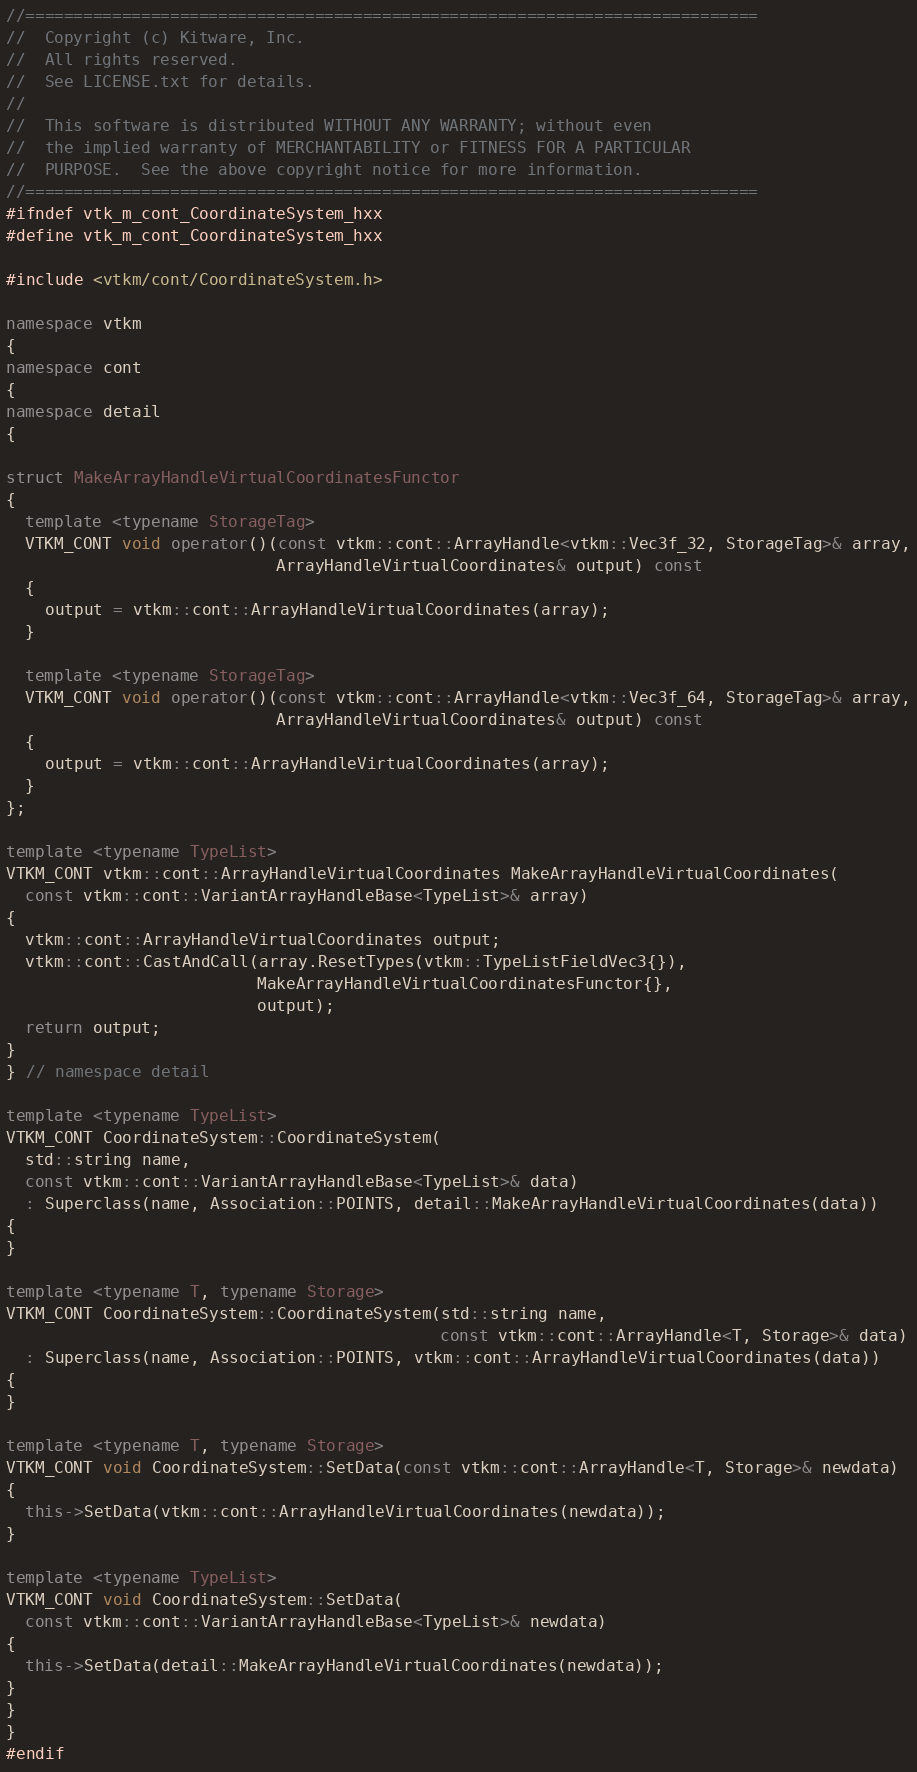<code> <loc_0><loc_0><loc_500><loc_500><_C++_>//============================================================================
//  Copyright (c) Kitware, Inc.
//  All rights reserved.
//  See LICENSE.txt for details.
//
//  This software is distributed WITHOUT ANY WARRANTY; without even
//  the implied warranty of MERCHANTABILITY or FITNESS FOR A PARTICULAR
//  PURPOSE.  See the above copyright notice for more information.
//============================================================================
#ifndef vtk_m_cont_CoordinateSystem_hxx
#define vtk_m_cont_CoordinateSystem_hxx

#include <vtkm/cont/CoordinateSystem.h>

namespace vtkm
{
namespace cont
{
namespace detail
{

struct MakeArrayHandleVirtualCoordinatesFunctor
{
  template <typename StorageTag>
  VTKM_CONT void operator()(const vtkm::cont::ArrayHandle<vtkm::Vec3f_32, StorageTag>& array,
                            ArrayHandleVirtualCoordinates& output) const
  {
    output = vtkm::cont::ArrayHandleVirtualCoordinates(array);
  }

  template <typename StorageTag>
  VTKM_CONT void operator()(const vtkm::cont::ArrayHandle<vtkm::Vec3f_64, StorageTag>& array,
                            ArrayHandleVirtualCoordinates& output) const
  {
    output = vtkm::cont::ArrayHandleVirtualCoordinates(array);
  }
};

template <typename TypeList>
VTKM_CONT vtkm::cont::ArrayHandleVirtualCoordinates MakeArrayHandleVirtualCoordinates(
  const vtkm::cont::VariantArrayHandleBase<TypeList>& array)
{
  vtkm::cont::ArrayHandleVirtualCoordinates output;
  vtkm::cont::CastAndCall(array.ResetTypes(vtkm::TypeListFieldVec3{}),
                          MakeArrayHandleVirtualCoordinatesFunctor{},
                          output);
  return output;
}
} // namespace detail

template <typename TypeList>
VTKM_CONT CoordinateSystem::CoordinateSystem(
  std::string name,
  const vtkm::cont::VariantArrayHandleBase<TypeList>& data)
  : Superclass(name, Association::POINTS, detail::MakeArrayHandleVirtualCoordinates(data))
{
}

template <typename T, typename Storage>
VTKM_CONT CoordinateSystem::CoordinateSystem(std::string name,
                                             const vtkm::cont::ArrayHandle<T, Storage>& data)
  : Superclass(name, Association::POINTS, vtkm::cont::ArrayHandleVirtualCoordinates(data))
{
}

template <typename T, typename Storage>
VTKM_CONT void CoordinateSystem::SetData(const vtkm::cont::ArrayHandle<T, Storage>& newdata)
{
  this->SetData(vtkm::cont::ArrayHandleVirtualCoordinates(newdata));
}

template <typename TypeList>
VTKM_CONT void CoordinateSystem::SetData(
  const vtkm::cont::VariantArrayHandleBase<TypeList>& newdata)
{
  this->SetData(detail::MakeArrayHandleVirtualCoordinates(newdata));
}
}
}
#endif
</code> 